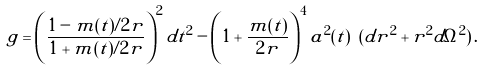<formula> <loc_0><loc_0><loc_500><loc_500>g = \left ( \frac { 1 - m ( t ) / 2 r } { 1 + m ( t ) / 2 r } \right ) ^ { 2 } d t ^ { 2 } - \left ( 1 + \frac { m ( t ) } { 2 r } \right ) ^ { 4 } a ^ { 2 } ( t ) \ ( d r ^ { 2 } + r ^ { 2 } d \Omega ^ { 2 } ) \, .</formula> 